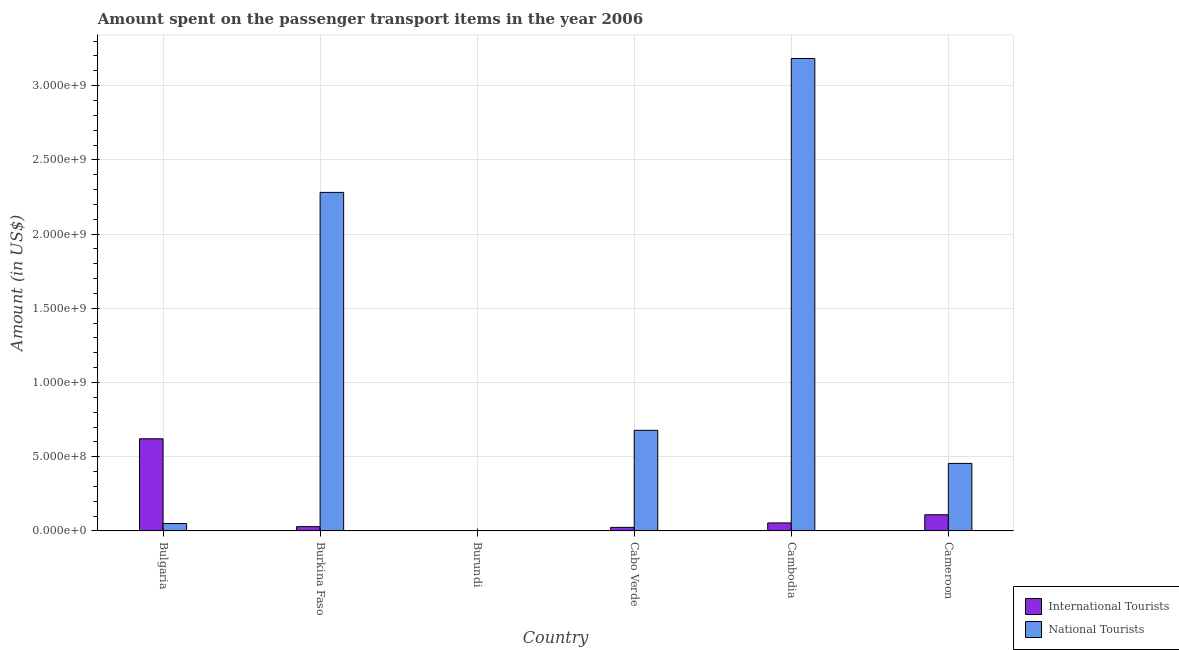How many bars are there on the 2nd tick from the left?
Keep it short and to the point. 2. How many bars are there on the 3rd tick from the right?
Ensure brevity in your answer.  2. What is the label of the 3rd group of bars from the left?
Keep it short and to the point. Burundi. What is the amount spent on transport items of international tourists in Cabo Verde?
Provide a succinct answer. 2.40e+07. Across all countries, what is the maximum amount spent on transport items of international tourists?
Make the answer very short. 6.21e+08. Across all countries, what is the minimum amount spent on transport items of international tourists?
Provide a short and direct response. 1.00e+06. In which country was the amount spent on transport items of national tourists minimum?
Offer a terse response. Burundi. What is the total amount spent on transport items of international tourists in the graph?
Make the answer very short. 8.38e+08. What is the difference between the amount spent on transport items of national tourists in Cabo Verde and that in Cambodia?
Provide a succinct answer. -2.50e+09. What is the difference between the amount spent on transport items of national tourists in Cambodia and the amount spent on transport items of international tourists in Bulgaria?
Give a very brief answer. 2.56e+09. What is the average amount spent on transport items of national tourists per country?
Keep it short and to the point. 1.11e+09. What is the difference between the amount spent on transport items of national tourists and amount spent on transport items of international tourists in Cameroon?
Your answer should be compact. 3.46e+08. What is the ratio of the amount spent on transport items of international tourists in Cambodia to that in Cameroon?
Provide a short and direct response. 0.5. What is the difference between the highest and the second highest amount spent on transport items of national tourists?
Ensure brevity in your answer.  9.02e+08. What is the difference between the highest and the lowest amount spent on transport items of national tourists?
Keep it short and to the point. 3.18e+09. In how many countries, is the amount spent on transport items of national tourists greater than the average amount spent on transport items of national tourists taken over all countries?
Give a very brief answer. 2. Is the sum of the amount spent on transport items of international tourists in Bulgaria and Cameroon greater than the maximum amount spent on transport items of national tourists across all countries?
Ensure brevity in your answer.  No. What does the 1st bar from the left in Burkina Faso represents?
Your response must be concise. International Tourists. What does the 2nd bar from the right in Burkina Faso represents?
Make the answer very short. International Tourists. How many bars are there?
Your answer should be very brief. 12. How many countries are there in the graph?
Provide a short and direct response. 6. Are the values on the major ticks of Y-axis written in scientific E-notation?
Your answer should be compact. Yes. Does the graph contain any zero values?
Make the answer very short. No. Does the graph contain grids?
Provide a short and direct response. Yes. Where does the legend appear in the graph?
Offer a terse response. Bottom right. How many legend labels are there?
Your answer should be very brief. 2. How are the legend labels stacked?
Offer a terse response. Vertical. What is the title of the graph?
Make the answer very short. Amount spent on the passenger transport items in the year 2006. What is the label or title of the Y-axis?
Your answer should be compact. Amount (in US$). What is the Amount (in US$) in International Tourists in Bulgaria?
Ensure brevity in your answer.  6.21e+08. What is the Amount (in US$) of National Tourists in Bulgaria?
Your answer should be very brief. 5.00e+07. What is the Amount (in US$) of International Tourists in Burkina Faso?
Your answer should be very brief. 2.90e+07. What is the Amount (in US$) of National Tourists in Burkina Faso?
Provide a short and direct response. 2.28e+09. What is the Amount (in US$) in International Tourists in Burundi?
Your answer should be compact. 1.00e+06. What is the Amount (in US$) in National Tourists in Burundi?
Provide a succinct answer. 2.20e+06. What is the Amount (in US$) in International Tourists in Cabo Verde?
Your response must be concise. 2.40e+07. What is the Amount (in US$) of National Tourists in Cabo Verde?
Offer a very short reply. 6.78e+08. What is the Amount (in US$) of International Tourists in Cambodia?
Keep it short and to the point. 5.40e+07. What is the Amount (in US$) of National Tourists in Cambodia?
Your answer should be compact. 3.18e+09. What is the Amount (in US$) of International Tourists in Cameroon?
Offer a very short reply. 1.09e+08. What is the Amount (in US$) of National Tourists in Cameroon?
Your answer should be compact. 4.55e+08. Across all countries, what is the maximum Amount (in US$) of International Tourists?
Make the answer very short. 6.21e+08. Across all countries, what is the maximum Amount (in US$) in National Tourists?
Ensure brevity in your answer.  3.18e+09. Across all countries, what is the minimum Amount (in US$) of International Tourists?
Provide a short and direct response. 1.00e+06. Across all countries, what is the minimum Amount (in US$) of National Tourists?
Your response must be concise. 2.20e+06. What is the total Amount (in US$) in International Tourists in the graph?
Offer a terse response. 8.38e+08. What is the total Amount (in US$) in National Tourists in the graph?
Your response must be concise. 6.65e+09. What is the difference between the Amount (in US$) in International Tourists in Bulgaria and that in Burkina Faso?
Your response must be concise. 5.92e+08. What is the difference between the Amount (in US$) in National Tourists in Bulgaria and that in Burkina Faso?
Give a very brief answer. -2.23e+09. What is the difference between the Amount (in US$) in International Tourists in Bulgaria and that in Burundi?
Offer a very short reply. 6.20e+08. What is the difference between the Amount (in US$) in National Tourists in Bulgaria and that in Burundi?
Offer a terse response. 4.78e+07. What is the difference between the Amount (in US$) of International Tourists in Bulgaria and that in Cabo Verde?
Offer a very short reply. 5.97e+08. What is the difference between the Amount (in US$) of National Tourists in Bulgaria and that in Cabo Verde?
Your response must be concise. -6.28e+08. What is the difference between the Amount (in US$) of International Tourists in Bulgaria and that in Cambodia?
Your answer should be compact. 5.67e+08. What is the difference between the Amount (in US$) of National Tourists in Bulgaria and that in Cambodia?
Provide a succinct answer. -3.13e+09. What is the difference between the Amount (in US$) of International Tourists in Bulgaria and that in Cameroon?
Your answer should be very brief. 5.12e+08. What is the difference between the Amount (in US$) in National Tourists in Bulgaria and that in Cameroon?
Give a very brief answer. -4.05e+08. What is the difference between the Amount (in US$) in International Tourists in Burkina Faso and that in Burundi?
Your response must be concise. 2.80e+07. What is the difference between the Amount (in US$) of National Tourists in Burkina Faso and that in Burundi?
Your response must be concise. 2.28e+09. What is the difference between the Amount (in US$) of National Tourists in Burkina Faso and that in Cabo Verde?
Your answer should be very brief. 1.60e+09. What is the difference between the Amount (in US$) of International Tourists in Burkina Faso and that in Cambodia?
Your answer should be compact. -2.50e+07. What is the difference between the Amount (in US$) of National Tourists in Burkina Faso and that in Cambodia?
Your answer should be compact. -9.02e+08. What is the difference between the Amount (in US$) of International Tourists in Burkina Faso and that in Cameroon?
Provide a succinct answer. -8.00e+07. What is the difference between the Amount (in US$) in National Tourists in Burkina Faso and that in Cameroon?
Your response must be concise. 1.83e+09. What is the difference between the Amount (in US$) of International Tourists in Burundi and that in Cabo Verde?
Ensure brevity in your answer.  -2.30e+07. What is the difference between the Amount (in US$) of National Tourists in Burundi and that in Cabo Verde?
Keep it short and to the point. -6.76e+08. What is the difference between the Amount (in US$) of International Tourists in Burundi and that in Cambodia?
Make the answer very short. -5.30e+07. What is the difference between the Amount (in US$) of National Tourists in Burundi and that in Cambodia?
Provide a short and direct response. -3.18e+09. What is the difference between the Amount (in US$) in International Tourists in Burundi and that in Cameroon?
Your response must be concise. -1.08e+08. What is the difference between the Amount (in US$) in National Tourists in Burundi and that in Cameroon?
Ensure brevity in your answer.  -4.53e+08. What is the difference between the Amount (in US$) of International Tourists in Cabo Verde and that in Cambodia?
Your response must be concise. -3.00e+07. What is the difference between the Amount (in US$) of National Tourists in Cabo Verde and that in Cambodia?
Offer a very short reply. -2.50e+09. What is the difference between the Amount (in US$) in International Tourists in Cabo Verde and that in Cameroon?
Offer a very short reply. -8.50e+07. What is the difference between the Amount (in US$) of National Tourists in Cabo Verde and that in Cameroon?
Your response must be concise. 2.23e+08. What is the difference between the Amount (in US$) in International Tourists in Cambodia and that in Cameroon?
Provide a short and direct response. -5.50e+07. What is the difference between the Amount (in US$) of National Tourists in Cambodia and that in Cameroon?
Provide a succinct answer. 2.73e+09. What is the difference between the Amount (in US$) of International Tourists in Bulgaria and the Amount (in US$) of National Tourists in Burkina Faso?
Offer a very short reply. -1.66e+09. What is the difference between the Amount (in US$) in International Tourists in Bulgaria and the Amount (in US$) in National Tourists in Burundi?
Your answer should be very brief. 6.19e+08. What is the difference between the Amount (in US$) of International Tourists in Bulgaria and the Amount (in US$) of National Tourists in Cabo Verde?
Your answer should be very brief. -5.70e+07. What is the difference between the Amount (in US$) of International Tourists in Bulgaria and the Amount (in US$) of National Tourists in Cambodia?
Your answer should be very brief. -2.56e+09. What is the difference between the Amount (in US$) in International Tourists in Bulgaria and the Amount (in US$) in National Tourists in Cameroon?
Keep it short and to the point. 1.66e+08. What is the difference between the Amount (in US$) of International Tourists in Burkina Faso and the Amount (in US$) of National Tourists in Burundi?
Your answer should be very brief. 2.68e+07. What is the difference between the Amount (in US$) in International Tourists in Burkina Faso and the Amount (in US$) in National Tourists in Cabo Verde?
Offer a very short reply. -6.49e+08. What is the difference between the Amount (in US$) in International Tourists in Burkina Faso and the Amount (in US$) in National Tourists in Cambodia?
Your answer should be compact. -3.15e+09. What is the difference between the Amount (in US$) of International Tourists in Burkina Faso and the Amount (in US$) of National Tourists in Cameroon?
Your answer should be compact. -4.26e+08. What is the difference between the Amount (in US$) of International Tourists in Burundi and the Amount (in US$) of National Tourists in Cabo Verde?
Your response must be concise. -6.77e+08. What is the difference between the Amount (in US$) in International Tourists in Burundi and the Amount (in US$) in National Tourists in Cambodia?
Offer a terse response. -3.18e+09. What is the difference between the Amount (in US$) in International Tourists in Burundi and the Amount (in US$) in National Tourists in Cameroon?
Your response must be concise. -4.54e+08. What is the difference between the Amount (in US$) in International Tourists in Cabo Verde and the Amount (in US$) in National Tourists in Cambodia?
Offer a very short reply. -3.16e+09. What is the difference between the Amount (in US$) in International Tourists in Cabo Verde and the Amount (in US$) in National Tourists in Cameroon?
Keep it short and to the point. -4.31e+08. What is the difference between the Amount (in US$) of International Tourists in Cambodia and the Amount (in US$) of National Tourists in Cameroon?
Your response must be concise. -4.01e+08. What is the average Amount (in US$) in International Tourists per country?
Provide a short and direct response. 1.40e+08. What is the average Amount (in US$) of National Tourists per country?
Make the answer very short. 1.11e+09. What is the difference between the Amount (in US$) in International Tourists and Amount (in US$) in National Tourists in Bulgaria?
Ensure brevity in your answer.  5.71e+08. What is the difference between the Amount (in US$) in International Tourists and Amount (in US$) in National Tourists in Burkina Faso?
Your answer should be very brief. -2.25e+09. What is the difference between the Amount (in US$) of International Tourists and Amount (in US$) of National Tourists in Burundi?
Provide a succinct answer. -1.20e+06. What is the difference between the Amount (in US$) of International Tourists and Amount (in US$) of National Tourists in Cabo Verde?
Offer a very short reply. -6.54e+08. What is the difference between the Amount (in US$) in International Tourists and Amount (in US$) in National Tourists in Cambodia?
Ensure brevity in your answer.  -3.13e+09. What is the difference between the Amount (in US$) of International Tourists and Amount (in US$) of National Tourists in Cameroon?
Provide a short and direct response. -3.46e+08. What is the ratio of the Amount (in US$) of International Tourists in Bulgaria to that in Burkina Faso?
Provide a short and direct response. 21.41. What is the ratio of the Amount (in US$) of National Tourists in Bulgaria to that in Burkina Faso?
Give a very brief answer. 0.02. What is the ratio of the Amount (in US$) in International Tourists in Bulgaria to that in Burundi?
Your answer should be compact. 621. What is the ratio of the Amount (in US$) in National Tourists in Bulgaria to that in Burundi?
Offer a very short reply. 22.73. What is the ratio of the Amount (in US$) of International Tourists in Bulgaria to that in Cabo Verde?
Offer a terse response. 25.88. What is the ratio of the Amount (in US$) of National Tourists in Bulgaria to that in Cabo Verde?
Make the answer very short. 0.07. What is the ratio of the Amount (in US$) of National Tourists in Bulgaria to that in Cambodia?
Offer a terse response. 0.02. What is the ratio of the Amount (in US$) of International Tourists in Bulgaria to that in Cameroon?
Offer a terse response. 5.7. What is the ratio of the Amount (in US$) in National Tourists in Bulgaria to that in Cameroon?
Your answer should be compact. 0.11. What is the ratio of the Amount (in US$) of National Tourists in Burkina Faso to that in Burundi?
Offer a very short reply. 1036.82. What is the ratio of the Amount (in US$) of International Tourists in Burkina Faso to that in Cabo Verde?
Your answer should be compact. 1.21. What is the ratio of the Amount (in US$) in National Tourists in Burkina Faso to that in Cabo Verde?
Ensure brevity in your answer.  3.36. What is the ratio of the Amount (in US$) in International Tourists in Burkina Faso to that in Cambodia?
Your answer should be very brief. 0.54. What is the ratio of the Amount (in US$) of National Tourists in Burkina Faso to that in Cambodia?
Your answer should be compact. 0.72. What is the ratio of the Amount (in US$) in International Tourists in Burkina Faso to that in Cameroon?
Your answer should be compact. 0.27. What is the ratio of the Amount (in US$) in National Tourists in Burkina Faso to that in Cameroon?
Ensure brevity in your answer.  5.01. What is the ratio of the Amount (in US$) of International Tourists in Burundi to that in Cabo Verde?
Offer a terse response. 0.04. What is the ratio of the Amount (in US$) of National Tourists in Burundi to that in Cabo Verde?
Keep it short and to the point. 0. What is the ratio of the Amount (in US$) of International Tourists in Burundi to that in Cambodia?
Your answer should be very brief. 0.02. What is the ratio of the Amount (in US$) in National Tourists in Burundi to that in Cambodia?
Make the answer very short. 0. What is the ratio of the Amount (in US$) in International Tourists in Burundi to that in Cameroon?
Offer a very short reply. 0.01. What is the ratio of the Amount (in US$) of National Tourists in Burundi to that in Cameroon?
Provide a succinct answer. 0. What is the ratio of the Amount (in US$) in International Tourists in Cabo Verde to that in Cambodia?
Your response must be concise. 0.44. What is the ratio of the Amount (in US$) of National Tourists in Cabo Verde to that in Cambodia?
Ensure brevity in your answer.  0.21. What is the ratio of the Amount (in US$) of International Tourists in Cabo Verde to that in Cameroon?
Offer a terse response. 0.22. What is the ratio of the Amount (in US$) in National Tourists in Cabo Verde to that in Cameroon?
Your response must be concise. 1.49. What is the ratio of the Amount (in US$) in International Tourists in Cambodia to that in Cameroon?
Your answer should be compact. 0.5. What is the ratio of the Amount (in US$) of National Tourists in Cambodia to that in Cameroon?
Provide a succinct answer. 7. What is the difference between the highest and the second highest Amount (in US$) in International Tourists?
Give a very brief answer. 5.12e+08. What is the difference between the highest and the second highest Amount (in US$) in National Tourists?
Your response must be concise. 9.02e+08. What is the difference between the highest and the lowest Amount (in US$) of International Tourists?
Your answer should be compact. 6.20e+08. What is the difference between the highest and the lowest Amount (in US$) of National Tourists?
Offer a very short reply. 3.18e+09. 